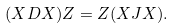<formula> <loc_0><loc_0><loc_500><loc_500>( X D X ) Z = Z ( X J X ) .</formula> 